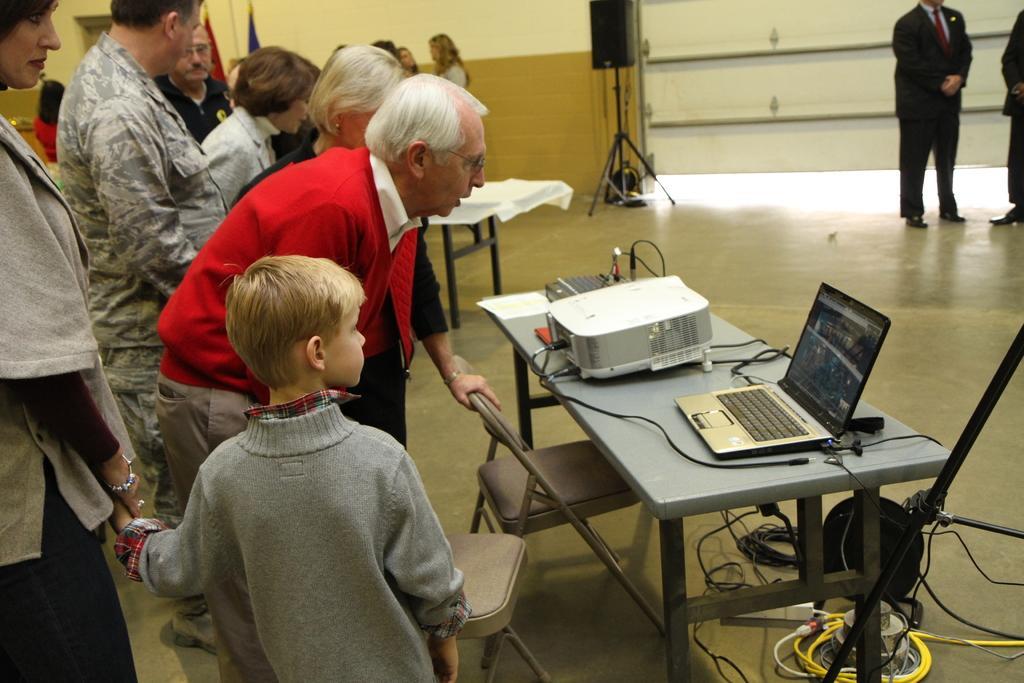How would you summarize this image in a sentence or two? There is a table on that there is a laptop and some people are standing and looking in the laptop and in the background there is wall and peoples are standing and talking. 